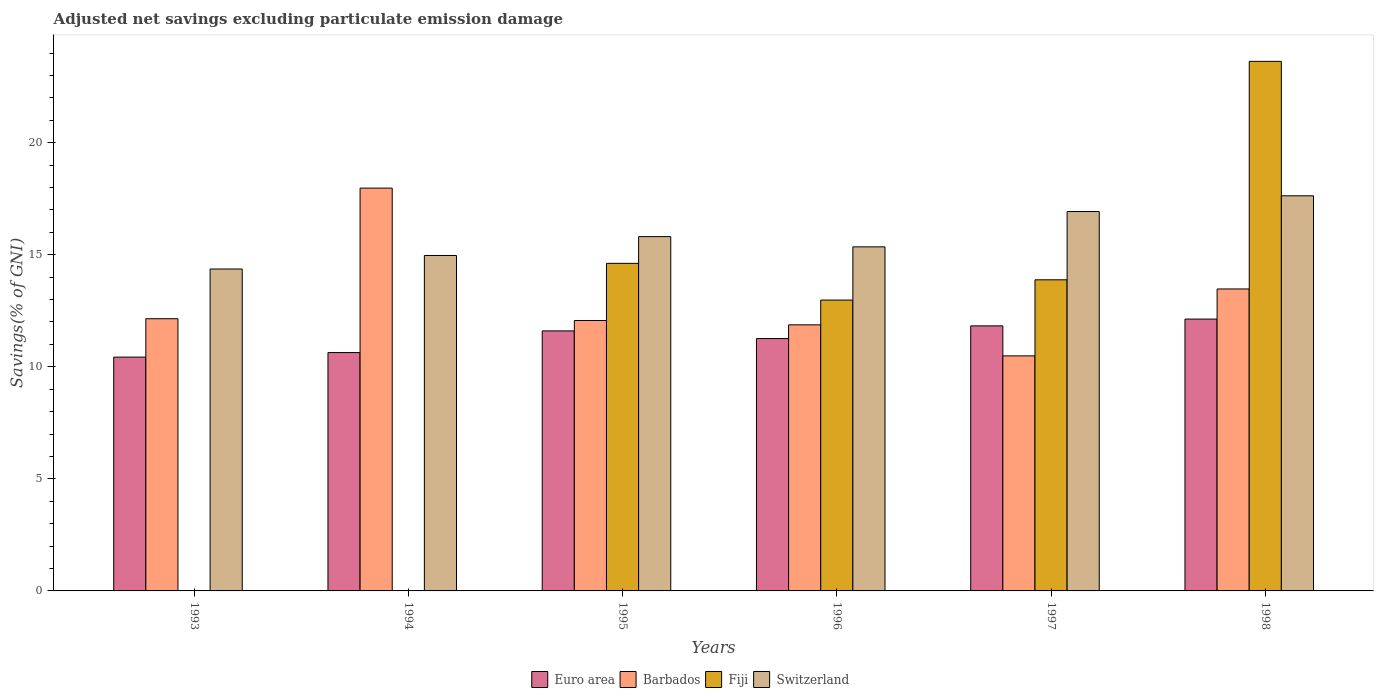How many different coloured bars are there?
Keep it short and to the point. 4. How many groups of bars are there?
Your answer should be very brief. 6. Are the number of bars per tick equal to the number of legend labels?
Your answer should be very brief. No. Are the number of bars on each tick of the X-axis equal?
Offer a very short reply. No. How many bars are there on the 4th tick from the left?
Offer a very short reply. 4. How many bars are there on the 6th tick from the right?
Ensure brevity in your answer.  3. What is the adjusted net savings in Switzerland in 1993?
Offer a very short reply. 14.36. Across all years, what is the maximum adjusted net savings in Euro area?
Make the answer very short. 12.13. Across all years, what is the minimum adjusted net savings in Barbados?
Give a very brief answer. 10.49. In which year was the adjusted net savings in Fiji maximum?
Make the answer very short. 1998. What is the total adjusted net savings in Switzerland in the graph?
Offer a very short reply. 95.05. What is the difference between the adjusted net savings in Switzerland in 1993 and that in 1996?
Give a very brief answer. -0.99. What is the difference between the adjusted net savings in Euro area in 1998 and the adjusted net savings in Switzerland in 1995?
Offer a terse response. -3.68. What is the average adjusted net savings in Euro area per year?
Keep it short and to the point. 11.31. In the year 1993, what is the difference between the adjusted net savings in Barbados and adjusted net savings in Euro area?
Your answer should be compact. 1.71. In how many years, is the adjusted net savings in Switzerland greater than 17 %?
Make the answer very short. 1. What is the ratio of the adjusted net savings in Euro area in 1993 to that in 1996?
Your answer should be compact. 0.93. What is the difference between the highest and the second highest adjusted net savings in Euro area?
Keep it short and to the point. 0.3. What is the difference between the highest and the lowest adjusted net savings in Switzerland?
Your answer should be compact. 3.27. In how many years, is the adjusted net savings in Barbados greater than the average adjusted net savings in Barbados taken over all years?
Your answer should be very brief. 2. Is it the case that in every year, the sum of the adjusted net savings in Euro area and adjusted net savings in Barbados is greater than the adjusted net savings in Fiji?
Make the answer very short. Yes. How many years are there in the graph?
Your response must be concise. 6. Are the values on the major ticks of Y-axis written in scientific E-notation?
Give a very brief answer. No. Does the graph contain any zero values?
Provide a succinct answer. Yes. Where does the legend appear in the graph?
Make the answer very short. Bottom center. How are the legend labels stacked?
Your answer should be compact. Horizontal. What is the title of the graph?
Provide a short and direct response. Adjusted net savings excluding particulate emission damage. Does "Mauritania" appear as one of the legend labels in the graph?
Provide a short and direct response. No. What is the label or title of the X-axis?
Ensure brevity in your answer.  Years. What is the label or title of the Y-axis?
Ensure brevity in your answer.  Savings(% of GNI). What is the Savings(% of GNI) of Euro area in 1993?
Offer a very short reply. 10.43. What is the Savings(% of GNI) of Barbados in 1993?
Make the answer very short. 12.15. What is the Savings(% of GNI) of Switzerland in 1993?
Keep it short and to the point. 14.36. What is the Savings(% of GNI) in Euro area in 1994?
Provide a short and direct response. 10.64. What is the Savings(% of GNI) in Barbados in 1994?
Ensure brevity in your answer.  17.97. What is the Savings(% of GNI) in Fiji in 1994?
Offer a terse response. 0. What is the Savings(% of GNI) of Switzerland in 1994?
Provide a succinct answer. 14.97. What is the Savings(% of GNI) of Euro area in 1995?
Provide a short and direct response. 11.6. What is the Savings(% of GNI) of Barbados in 1995?
Make the answer very short. 12.07. What is the Savings(% of GNI) in Fiji in 1995?
Give a very brief answer. 14.62. What is the Savings(% of GNI) in Switzerland in 1995?
Your answer should be very brief. 15.81. What is the Savings(% of GNI) in Euro area in 1996?
Keep it short and to the point. 11.26. What is the Savings(% of GNI) in Barbados in 1996?
Your response must be concise. 11.87. What is the Savings(% of GNI) in Fiji in 1996?
Your answer should be very brief. 12.98. What is the Savings(% of GNI) of Switzerland in 1996?
Your answer should be very brief. 15.35. What is the Savings(% of GNI) in Euro area in 1997?
Ensure brevity in your answer.  11.83. What is the Savings(% of GNI) of Barbados in 1997?
Keep it short and to the point. 10.49. What is the Savings(% of GNI) of Fiji in 1997?
Ensure brevity in your answer.  13.88. What is the Savings(% of GNI) of Switzerland in 1997?
Your answer should be very brief. 16.93. What is the Savings(% of GNI) of Euro area in 1998?
Your response must be concise. 12.13. What is the Savings(% of GNI) of Barbados in 1998?
Make the answer very short. 13.47. What is the Savings(% of GNI) of Fiji in 1998?
Provide a short and direct response. 23.63. What is the Savings(% of GNI) in Switzerland in 1998?
Provide a short and direct response. 17.63. Across all years, what is the maximum Savings(% of GNI) of Euro area?
Your response must be concise. 12.13. Across all years, what is the maximum Savings(% of GNI) in Barbados?
Make the answer very short. 17.97. Across all years, what is the maximum Savings(% of GNI) in Fiji?
Provide a succinct answer. 23.63. Across all years, what is the maximum Savings(% of GNI) of Switzerland?
Offer a terse response. 17.63. Across all years, what is the minimum Savings(% of GNI) of Euro area?
Your answer should be very brief. 10.43. Across all years, what is the minimum Savings(% of GNI) in Barbados?
Ensure brevity in your answer.  10.49. Across all years, what is the minimum Savings(% of GNI) in Fiji?
Ensure brevity in your answer.  0. Across all years, what is the minimum Savings(% of GNI) in Switzerland?
Keep it short and to the point. 14.36. What is the total Savings(% of GNI) of Euro area in the graph?
Ensure brevity in your answer.  67.89. What is the total Savings(% of GNI) of Barbados in the graph?
Make the answer very short. 78.02. What is the total Savings(% of GNI) of Fiji in the graph?
Your answer should be very brief. 65.1. What is the total Savings(% of GNI) in Switzerland in the graph?
Your answer should be compact. 95.05. What is the difference between the Savings(% of GNI) in Euro area in 1993 and that in 1994?
Your answer should be compact. -0.2. What is the difference between the Savings(% of GNI) of Barbados in 1993 and that in 1994?
Your answer should be very brief. -5.83. What is the difference between the Savings(% of GNI) of Switzerland in 1993 and that in 1994?
Make the answer very short. -0.6. What is the difference between the Savings(% of GNI) of Euro area in 1993 and that in 1995?
Offer a terse response. -1.17. What is the difference between the Savings(% of GNI) in Barbados in 1993 and that in 1995?
Ensure brevity in your answer.  0.08. What is the difference between the Savings(% of GNI) of Switzerland in 1993 and that in 1995?
Make the answer very short. -1.45. What is the difference between the Savings(% of GNI) in Euro area in 1993 and that in 1996?
Provide a succinct answer. -0.83. What is the difference between the Savings(% of GNI) of Barbados in 1993 and that in 1996?
Offer a very short reply. 0.27. What is the difference between the Savings(% of GNI) of Switzerland in 1993 and that in 1996?
Provide a succinct answer. -0.99. What is the difference between the Savings(% of GNI) in Euro area in 1993 and that in 1997?
Your response must be concise. -1.39. What is the difference between the Savings(% of GNI) of Barbados in 1993 and that in 1997?
Ensure brevity in your answer.  1.66. What is the difference between the Savings(% of GNI) in Switzerland in 1993 and that in 1997?
Your answer should be compact. -2.56. What is the difference between the Savings(% of GNI) in Euro area in 1993 and that in 1998?
Provide a short and direct response. -1.7. What is the difference between the Savings(% of GNI) of Barbados in 1993 and that in 1998?
Provide a succinct answer. -1.33. What is the difference between the Savings(% of GNI) in Switzerland in 1993 and that in 1998?
Your answer should be very brief. -3.27. What is the difference between the Savings(% of GNI) in Euro area in 1994 and that in 1995?
Provide a short and direct response. -0.97. What is the difference between the Savings(% of GNI) in Barbados in 1994 and that in 1995?
Provide a short and direct response. 5.91. What is the difference between the Savings(% of GNI) in Switzerland in 1994 and that in 1995?
Your response must be concise. -0.84. What is the difference between the Savings(% of GNI) in Euro area in 1994 and that in 1996?
Offer a very short reply. -0.62. What is the difference between the Savings(% of GNI) of Barbados in 1994 and that in 1996?
Provide a succinct answer. 6.1. What is the difference between the Savings(% of GNI) of Switzerland in 1994 and that in 1996?
Give a very brief answer. -0.39. What is the difference between the Savings(% of GNI) of Euro area in 1994 and that in 1997?
Your answer should be very brief. -1.19. What is the difference between the Savings(% of GNI) of Barbados in 1994 and that in 1997?
Provide a succinct answer. 7.49. What is the difference between the Savings(% of GNI) of Switzerland in 1994 and that in 1997?
Offer a very short reply. -1.96. What is the difference between the Savings(% of GNI) in Euro area in 1994 and that in 1998?
Ensure brevity in your answer.  -1.49. What is the difference between the Savings(% of GNI) in Barbados in 1994 and that in 1998?
Make the answer very short. 4.5. What is the difference between the Savings(% of GNI) in Switzerland in 1994 and that in 1998?
Your answer should be compact. -2.66. What is the difference between the Savings(% of GNI) in Euro area in 1995 and that in 1996?
Make the answer very short. 0.34. What is the difference between the Savings(% of GNI) in Barbados in 1995 and that in 1996?
Offer a terse response. 0.19. What is the difference between the Savings(% of GNI) of Fiji in 1995 and that in 1996?
Keep it short and to the point. 1.64. What is the difference between the Savings(% of GNI) of Switzerland in 1995 and that in 1996?
Provide a short and direct response. 0.46. What is the difference between the Savings(% of GNI) of Euro area in 1995 and that in 1997?
Offer a terse response. -0.22. What is the difference between the Savings(% of GNI) in Barbados in 1995 and that in 1997?
Provide a succinct answer. 1.58. What is the difference between the Savings(% of GNI) of Fiji in 1995 and that in 1997?
Your answer should be compact. 0.73. What is the difference between the Savings(% of GNI) in Switzerland in 1995 and that in 1997?
Provide a succinct answer. -1.12. What is the difference between the Savings(% of GNI) in Euro area in 1995 and that in 1998?
Give a very brief answer. -0.53. What is the difference between the Savings(% of GNI) of Barbados in 1995 and that in 1998?
Offer a very short reply. -1.41. What is the difference between the Savings(% of GNI) in Fiji in 1995 and that in 1998?
Offer a terse response. -9.01. What is the difference between the Savings(% of GNI) of Switzerland in 1995 and that in 1998?
Ensure brevity in your answer.  -1.82. What is the difference between the Savings(% of GNI) of Euro area in 1996 and that in 1997?
Keep it short and to the point. -0.57. What is the difference between the Savings(% of GNI) of Barbados in 1996 and that in 1997?
Ensure brevity in your answer.  1.39. What is the difference between the Savings(% of GNI) of Fiji in 1996 and that in 1997?
Your response must be concise. -0.9. What is the difference between the Savings(% of GNI) in Switzerland in 1996 and that in 1997?
Provide a short and direct response. -1.58. What is the difference between the Savings(% of GNI) of Euro area in 1996 and that in 1998?
Give a very brief answer. -0.87. What is the difference between the Savings(% of GNI) of Barbados in 1996 and that in 1998?
Offer a very short reply. -1.6. What is the difference between the Savings(% of GNI) of Fiji in 1996 and that in 1998?
Provide a succinct answer. -10.65. What is the difference between the Savings(% of GNI) of Switzerland in 1996 and that in 1998?
Offer a terse response. -2.28. What is the difference between the Savings(% of GNI) of Euro area in 1997 and that in 1998?
Your response must be concise. -0.3. What is the difference between the Savings(% of GNI) in Barbados in 1997 and that in 1998?
Provide a short and direct response. -2.99. What is the difference between the Savings(% of GNI) of Fiji in 1997 and that in 1998?
Provide a succinct answer. -9.75. What is the difference between the Savings(% of GNI) of Switzerland in 1997 and that in 1998?
Offer a very short reply. -0.7. What is the difference between the Savings(% of GNI) of Euro area in 1993 and the Savings(% of GNI) of Barbados in 1994?
Provide a succinct answer. -7.54. What is the difference between the Savings(% of GNI) of Euro area in 1993 and the Savings(% of GNI) of Switzerland in 1994?
Provide a succinct answer. -4.53. What is the difference between the Savings(% of GNI) of Barbados in 1993 and the Savings(% of GNI) of Switzerland in 1994?
Ensure brevity in your answer.  -2.82. What is the difference between the Savings(% of GNI) of Euro area in 1993 and the Savings(% of GNI) of Barbados in 1995?
Offer a very short reply. -1.63. What is the difference between the Savings(% of GNI) of Euro area in 1993 and the Savings(% of GNI) of Fiji in 1995?
Your answer should be compact. -4.18. What is the difference between the Savings(% of GNI) in Euro area in 1993 and the Savings(% of GNI) in Switzerland in 1995?
Make the answer very short. -5.38. What is the difference between the Savings(% of GNI) of Barbados in 1993 and the Savings(% of GNI) of Fiji in 1995?
Offer a very short reply. -2.47. What is the difference between the Savings(% of GNI) in Barbados in 1993 and the Savings(% of GNI) in Switzerland in 1995?
Keep it short and to the point. -3.66. What is the difference between the Savings(% of GNI) of Euro area in 1993 and the Savings(% of GNI) of Barbados in 1996?
Make the answer very short. -1.44. What is the difference between the Savings(% of GNI) of Euro area in 1993 and the Savings(% of GNI) of Fiji in 1996?
Provide a succinct answer. -2.55. What is the difference between the Savings(% of GNI) of Euro area in 1993 and the Savings(% of GNI) of Switzerland in 1996?
Your answer should be compact. -4.92. What is the difference between the Savings(% of GNI) in Barbados in 1993 and the Savings(% of GNI) in Fiji in 1996?
Make the answer very short. -0.83. What is the difference between the Savings(% of GNI) of Barbados in 1993 and the Savings(% of GNI) of Switzerland in 1996?
Provide a succinct answer. -3.21. What is the difference between the Savings(% of GNI) of Euro area in 1993 and the Savings(% of GNI) of Barbados in 1997?
Keep it short and to the point. -0.06. What is the difference between the Savings(% of GNI) of Euro area in 1993 and the Savings(% of GNI) of Fiji in 1997?
Offer a terse response. -3.45. What is the difference between the Savings(% of GNI) of Euro area in 1993 and the Savings(% of GNI) of Switzerland in 1997?
Make the answer very short. -6.5. What is the difference between the Savings(% of GNI) of Barbados in 1993 and the Savings(% of GNI) of Fiji in 1997?
Offer a very short reply. -1.74. What is the difference between the Savings(% of GNI) in Barbados in 1993 and the Savings(% of GNI) in Switzerland in 1997?
Provide a short and direct response. -4.78. What is the difference between the Savings(% of GNI) of Euro area in 1993 and the Savings(% of GNI) of Barbados in 1998?
Your answer should be very brief. -3.04. What is the difference between the Savings(% of GNI) in Euro area in 1993 and the Savings(% of GNI) in Fiji in 1998?
Keep it short and to the point. -13.2. What is the difference between the Savings(% of GNI) of Euro area in 1993 and the Savings(% of GNI) of Switzerland in 1998?
Your answer should be very brief. -7.2. What is the difference between the Savings(% of GNI) of Barbados in 1993 and the Savings(% of GNI) of Fiji in 1998?
Ensure brevity in your answer.  -11.48. What is the difference between the Savings(% of GNI) in Barbados in 1993 and the Savings(% of GNI) in Switzerland in 1998?
Ensure brevity in your answer.  -5.48. What is the difference between the Savings(% of GNI) of Euro area in 1994 and the Savings(% of GNI) of Barbados in 1995?
Keep it short and to the point. -1.43. What is the difference between the Savings(% of GNI) of Euro area in 1994 and the Savings(% of GNI) of Fiji in 1995?
Your response must be concise. -3.98. What is the difference between the Savings(% of GNI) of Euro area in 1994 and the Savings(% of GNI) of Switzerland in 1995?
Provide a short and direct response. -5.17. What is the difference between the Savings(% of GNI) in Barbados in 1994 and the Savings(% of GNI) in Fiji in 1995?
Your answer should be very brief. 3.36. What is the difference between the Savings(% of GNI) in Barbados in 1994 and the Savings(% of GNI) in Switzerland in 1995?
Your answer should be compact. 2.16. What is the difference between the Savings(% of GNI) in Euro area in 1994 and the Savings(% of GNI) in Barbados in 1996?
Offer a terse response. -1.24. What is the difference between the Savings(% of GNI) in Euro area in 1994 and the Savings(% of GNI) in Fiji in 1996?
Offer a terse response. -2.34. What is the difference between the Savings(% of GNI) in Euro area in 1994 and the Savings(% of GNI) in Switzerland in 1996?
Your answer should be very brief. -4.72. What is the difference between the Savings(% of GNI) of Barbados in 1994 and the Savings(% of GNI) of Fiji in 1996?
Ensure brevity in your answer.  5. What is the difference between the Savings(% of GNI) in Barbados in 1994 and the Savings(% of GNI) in Switzerland in 1996?
Your answer should be compact. 2.62. What is the difference between the Savings(% of GNI) of Euro area in 1994 and the Savings(% of GNI) of Barbados in 1997?
Provide a short and direct response. 0.15. What is the difference between the Savings(% of GNI) of Euro area in 1994 and the Savings(% of GNI) of Fiji in 1997?
Provide a short and direct response. -3.25. What is the difference between the Savings(% of GNI) of Euro area in 1994 and the Savings(% of GNI) of Switzerland in 1997?
Your response must be concise. -6.29. What is the difference between the Savings(% of GNI) in Barbados in 1994 and the Savings(% of GNI) in Fiji in 1997?
Your answer should be compact. 4.09. What is the difference between the Savings(% of GNI) in Barbados in 1994 and the Savings(% of GNI) in Switzerland in 1997?
Give a very brief answer. 1.05. What is the difference between the Savings(% of GNI) in Euro area in 1994 and the Savings(% of GNI) in Barbados in 1998?
Offer a terse response. -2.84. What is the difference between the Savings(% of GNI) of Euro area in 1994 and the Savings(% of GNI) of Fiji in 1998?
Provide a short and direct response. -12.99. What is the difference between the Savings(% of GNI) in Euro area in 1994 and the Savings(% of GNI) in Switzerland in 1998?
Offer a terse response. -6.99. What is the difference between the Savings(% of GNI) of Barbados in 1994 and the Savings(% of GNI) of Fiji in 1998?
Your response must be concise. -5.66. What is the difference between the Savings(% of GNI) of Barbados in 1994 and the Savings(% of GNI) of Switzerland in 1998?
Your answer should be very brief. 0.34. What is the difference between the Savings(% of GNI) of Euro area in 1995 and the Savings(% of GNI) of Barbados in 1996?
Offer a terse response. -0.27. What is the difference between the Savings(% of GNI) of Euro area in 1995 and the Savings(% of GNI) of Fiji in 1996?
Your answer should be very brief. -1.37. What is the difference between the Savings(% of GNI) of Euro area in 1995 and the Savings(% of GNI) of Switzerland in 1996?
Provide a short and direct response. -3.75. What is the difference between the Savings(% of GNI) in Barbados in 1995 and the Savings(% of GNI) in Fiji in 1996?
Provide a succinct answer. -0.91. What is the difference between the Savings(% of GNI) of Barbados in 1995 and the Savings(% of GNI) of Switzerland in 1996?
Provide a succinct answer. -3.29. What is the difference between the Savings(% of GNI) of Fiji in 1995 and the Savings(% of GNI) of Switzerland in 1996?
Offer a terse response. -0.74. What is the difference between the Savings(% of GNI) in Euro area in 1995 and the Savings(% of GNI) in Barbados in 1997?
Give a very brief answer. 1.12. What is the difference between the Savings(% of GNI) of Euro area in 1995 and the Savings(% of GNI) of Fiji in 1997?
Your answer should be compact. -2.28. What is the difference between the Savings(% of GNI) in Euro area in 1995 and the Savings(% of GNI) in Switzerland in 1997?
Provide a succinct answer. -5.33. What is the difference between the Savings(% of GNI) of Barbados in 1995 and the Savings(% of GNI) of Fiji in 1997?
Make the answer very short. -1.82. What is the difference between the Savings(% of GNI) in Barbados in 1995 and the Savings(% of GNI) in Switzerland in 1997?
Your answer should be very brief. -4.86. What is the difference between the Savings(% of GNI) of Fiji in 1995 and the Savings(% of GNI) of Switzerland in 1997?
Make the answer very short. -2.31. What is the difference between the Savings(% of GNI) of Euro area in 1995 and the Savings(% of GNI) of Barbados in 1998?
Offer a very short reply. -1.87. What is the difference between the Savings(% of GNI) of Euro area in 1995 and the Savings(% of GNI) of Fiji in 1998?
Provide a short and direct response. -12.03. What is the difference between the Savings(% of GNI) of Euro area in 1995 and the Savings(% of GNI) of Switzerland in 1998?
Ensure brevity in your answer.  -6.03. What is the difference between the Savings(% of GNI) in Barbados in 1995 and the Savings(% of GNI) in Fiji in 1998?
Make the answer very short. -11.56. What is the difference between the Savings(% of GNI) in Barbados in 1995 and the Savings(% of GNI) in Switzerland in 1998?
Your answer should be compact. -5.56. What is the difference between the Savings(% of GNI) of Fiji in 1995 and the Savings(% of GNI) of Switzerland in 1998?
Your response must be concise. -3.01. What is the difference between the Savings(% of GNI) of Euro area in 1996 and the Savings(% of GNI) of Barbados in 1997?
Give a very brief answer. 0.77. What is the difference between the Savings(% of GNI) in Euro area in 1996 and the Savings(% of GNI) in Fiji in 1997?
Ensure brevity in your answer.  -2.62. What is the difference between the Savings(% of GNI) of Euro area in 1996 and the Savings(% of GNI) of Switzerland in 1997?
Give a very brief answer. -5.67. What is the difference between the Savings(% of GNI) in Barbados in 1996 and the Savings(% of GNI) in Fiji in 1997?
Give a very brief answer. -2.01. What is the difference between the Savings(% of GNI) of Barbados in 1996 and the Savings(% of GNI) of Switzerland in 1997?
Your answer should be very brief. -5.06. What is the difference between the Savings(% of GNI) of Fiji in 1996 and the Savings(% of GNI) of Switzerland in 1997?
Your answer should be compact. -3.95. What is the difference between the Savings(% of GNI) in Euro area in 1996 and the Savings(% of GNI) in Barbados in 1998?
Your answer should be compact. -2.21. What is the difference between the Savings(% of GNI) in Euro area in 1996 and the Savings(% of GNI) in Fiji in 1998?
Your answer should be very brief. -12.37. What is the difference between the Savings(% of GNI) of Euro area in 1996 and the Savings(% of GNI) of Switzerland in 1998?
Make the answer very short. -6.37. What is the difference between the Savings(% of GNI) of Barbados in 1996 and the Savings(% of GNI) of Fiji in 1998?
Your answer should be compact. -11.76. What is the difference between the Savings(% of GNI) of Barbados in 1996 and the Savings(% of GNI) of Switzerland in 1998?
Ensure brevity in your answer.  -5.76. What is the difference between the Savings(% of GNI) of Fiji in 1996 and the Savings(% of GNI) of Switzerland in 1998?
Your response must be concise. -4.65. What is the difference between the Savings(% of GNI) of Euro area in 1997 and the Savings(% of GNI) of Barbados in 1998?
Provide a short and direct response. -1.65. What is the difference between the Savings(% of GNI) of Euro area in 1997 and the Savings(% of GNI) of Fiji in 1998?
Ensure brevity in your answer.  -11.8. What is the difference between the Savings(% of GNI) of Euro area in 1997 and the Savings(% of GNI) of Switzerland in 1998?
Ensure brevity in your answer.  -5.8. What is the difference between the Savings(% of GNI) in Barbados in 1997 and the Savings(% of GNI) in Fiji in 1998?
Offer a terse response. -13.14. What is the difference between the Savings(% of GNI) in Barbados in 1997 and the Savings(% of GNI) in Switzerland in 1998?
Your answer should be compact. -7.14. What is the difference between the Savings(% of GNI) of Fiji in 1997 and the Savings(% of GNI) of Switzerland in 1998?
Your response must be concise. -3.75. What is the average Savings(% of GNI) in Euro area per year?
Make the answer very short. 11.31. What is the average Savings(% of GNI) in Barbados per year?
Give a very brief answer. 13. What is the average Savings(% of GNI) of Fiji per year?
Your answer should be compact. 10.85. What is the average Savings(% of GNI) in Switzerland per year?
Your answer should be compact. 15.84. In the year 1993, what is the difference between the Savings(% of GNI) of Euro area and Savings(% of GNI) of Barbados?
Make the answer very short. -1.71. In the year 1993, what is the difference between the Savings(% of GNI) of Euro area and Savings(% of GNI) of Switzerland?
Provide a short and direct response. -3.93. In the year 1993, what is the difference between the Savings(% of GNI) of Barbados and Savings(% of GNI) of Switzerland?
Provide a short and direct response. -2.22. In the year 1994, what is the difference between the Savings(% of GNI) in Euro area and Savings(% of GNI) in Barbados?
Make the answer very short. -7.34. In the year 1994, what is the difference between the Savings(% of GNI) in Euro area and Savings(% of GNI) in Switzerland?
Give a very brief answer. -4.33. In the year 1994, what is the difference between the Savings(% of GNI) of Barbados and Savings(% of GNI) of Switzerland?
Ensure brevity in your answer.  3.01. In the year 1995, what is the difference between the Savings(% of GNI) of Euro area and Savings(% of GNI) of Barbados?
Give a very brief answer. -0.46. In the year 1995, what is the difference between the Savings(% of GNI) in Euro area and Savings(% of GNI) in Fiji?
Your answer should be compact. -3.01. In the year 1995, what is the difference between the Savings(% of GNI) in Euro area and Savings(% of GNI) in Switzerland?
Keep it short and to the point. -4.21. In the year 1995, what is the difference between the Savings(% of GNI) of Barbados and Savings(% of GNI) of Fiji?
Offer a terse response. -2.55. In the year 1995, what is the difference between the Savings(% of GNI) in Barbados and Savings(% of GNI) in Switzerland?
Your response must be concise. -3.74. In the year 1995, what is the difference between the Savings(% of GNI) in Fiji and Savings(% of GNI) in Switzerland?
Ensure brevity in your answer.  -1.19. In the year 1996, what is the difference between the Savings(% of GNI) of Euro area and Savings(% of GNI) of Barbados?
Your answer should be compact. -0.61. In the year 1996, what is the difference between the Savings(% of GNI) in Euro area and Savings(% of GNI) in Fiji?
Make the answer very short. -1.72. In the year 1996, what is the difference between the Savings(% of GNI) of Euro area and Savings(% of GNI) of Switzerland?
Make the answer very short. -4.09. In the year 1996, what is the difference between the Savings(% of GNI) in Barbados and Savings(% of GNI) in Fiji?
Offer a very short reply. -1.1. In the year 1996, what is the difference between the Savings(% of GNI) in Barbados and Savings(% of GNI) in Switzerland?
Your answer should be very brief. -3.48. In the year 1996, what is the difference between the Savings(% of GNI) of Fiji and Savings(% of GNI) of Switzerland?
Provide a short and direct response. -2.38. In the year 1997, what is the difference between the Savings(% of GNI) of Euro area and Savings(% of GNI) of Barbados?
Your answer should be very brief. 1.34. In the year 1997, what is the difference between the Savings(% of GNI) of Euro area and Savings(% of GNI) of Fiji?
Keep it short and to the point. -2.06. In the year 1997, what is the difference between the Savings(% of GNI) of Euro area and Savings(% of GNI) of Switzerland?
Your answer should be very brief. -5.1. In the year 1997, what is the difference between the Savings(% of GNI) in Barbados and Savings(% of GNI) in Fiji?
Ensure brevity in your answer.  -3.39. In the year 1997, what is the difference between the Savings(% of GNI) in Barbados and Savings(% of GNI) in Switzerland?
Make the answer very short. -6.44. In the year 1997, what is the difference between the Savings(% of GNI) in Fiji and Savings(% of GNI) in Switzerland?
Your response must be concise. -3.05. In the year 1998, what is the difference between the Savings(% of GNI) in Euro area and Savings(% of GNI) in Barbados?
Provide a succinct answer. -1.34. In the year 1998, what is the difference between the Savings(% of GNI) of Euro area and Savings(% of GNI) of Fiji?
Keep it short and to the point. -11.5. In the year 1998, what is the difference between the Savings(% of GNI) in Euro area and Savings(% of GNI) in Switzerland?
Provide a short and direct response. -5.5. In the year 1998, what is the difference between the Savings(% of GNI) in Barbados and Savings(% of GNI) in Fiji?
Provide a short and direct response. -10.16. In the year 1998, what is the difference between the Savings(% of GNI) of Barbados and Savings(% of GNI) of Switzerland?
Provide a short and direct response. -4.16. In the year 1998, what is the difference between the Savings(% of GNI) of Fiji and Savings(% of GNI) of Switzerland?
Ensure brevity in your answer.  6. What is the ratio of the Savings(% of GNI) in Euro area in 1993 to that in 1994?
Your response must be concise. 0.98. What is the ratio of the Savings(% of GNI) of Barbados in 1993 to that in 1994?
Your answer should be compact. 0.68. What is the ratio of the Savings(% of GNI) of Switzerland in 1993 to that in 1994?
Give a very brief answer. 0.96. What is the ratio of the Savings(% of GNI) in Euro area in 1993 to that in 1995?
Your answer should be compact. 0.9. What is the ratio of the Savings(% of GNI) in Barbados in 1993 to that in 1995?
Your response must be concise. 1.01. What is the ratio of the Savings(% of GNI) of Switzerland in 1993 to that in 1995?
Your answer should be compact. 0.91. What is the ratio of the Savings(% of GNI) of Euro area in 1993 to that in 1996?
Give a very brief answer. 0.93. What is the ratio of the Savings(% of GNI) in Switzerland in 1993 to that in 1996?
Provide a succinct answer. 0.94. What is the ratio of the Savings(% of GNI) of Euro area in 1993 to that in 1997?
Offer a very short reply. 0.88. What is the ratio of the Savings(% of GNI) in Barbados in 1993 to that in 1997?
Your answer should be very brief. 1.16. What is the ratio of the Savings(% of GNI) of Switzerland in 1993 to that in 1997?
Offer a terse response. 0.85. What is the ratio of the Savings(% of GNI) of Euro area in 1993 to that in 1998?
Your answer should be very brief. 0.86. What is the ratio of the Savings(% of GNI) in Barbados in 1993 to that in 1998?
Give a very brief answer. 0.9. What is the ratio of the Savings(% of GNI) in Switzerland in 1993 to that in 1998?
Your answer should be compact. 0.81. What is the ratio of the Savings(% of GNI) of Euro area in 1994 to that in 1995?
Provide a short and direct response. 0.92. What is the ratio of the Savings(% of GNI) in Barbados in 1994 to that in 1995?
Your answer should be very brief. 1.49. What is the ratio of the Savings(% of GNI) of Switzerland in 1994 to that in 1995?
Keep it short and to the point. 0.95. What is the ratio of the Savings(% of GNI) of Euro area in 1994 to that in 1996?
Your response must be concise. 0.94. What is the ratio of the Savings(% of GNI) of Barbados in 1994 to that in 1996?
Your answer should be very brief. 1.51. What is the ratio of the Savings(% of GNI) in Switzerland in 1994 to that in 1996?
Offer a terse response. 0.97. What is the ratio of the Savings(% of GNI) of Euro area in 1994 to that in 1997?
Keep it short and to the point. 0.9. What is the ratio of the Savings(% of GNI) of Barbados in 1994 to that in 1997?
Provide a short and direct response. 1.71. What is the ratio of the Savings(% of GNI) in Switzerland in 1994 to that in 1997?
Your answer should be compact. 0.88. What is the ratio of the Savings(% of GNI) in Euro area in 1994 to that in 1998?
Provide a short and direct response. 0.88. What is the ratio of the Savings(% of GNI) in Barbados in 1994 to that in 1998?
Make the answer very short. 1.33. What is the ratio of the Savings(% of GNI) of Switzerland in 1994 to that in 1998?
Offer a terse response. 0.85. What is the ratio of the Savings(% of GNI) of Euro area in 1995 to that in 1996?
Your answer should be very brief. 1.03. What is the ratio of the Savings(% of GNI) in Barbados in 1995 to that in 1996?
Your answer should be compact. 1.02. What is the ratio of the Savings(% of GNI) of Fiji in 1995 to that in 1996?
Make the answer very short. 1.13. What is the ratio of the Savings(% of GNI) of Switzerland in 1995 to that in 1996?
Your response must be concise. 1.03. What is the ratio of the Savings(% of GNI) of Barbados in 1995 to that in 1997?
Provide a short and direct response. 1.15. What is the ratio of the Savings(% of GNI) in Fiji in 1995 to that in 1997?
Your response must be concise. 1.05. What is the ratio of the Savings(% of GNI) of Switzerland in 1995 to that in 1997?
Provide a succinct answer. 0.93. What is the ratio of the Savings(% of GNI) in Euro area in 1995 to that in 1998?
Your response must be concise. 0.96. What is the ratio of the Savings(% of GNI) in Barbados in 1995 to that in 1998?
Your answer should be very brief. 0.9. What is the ratio of the Savings(% of GNI) in Fiji in 1995 to that in 1998?
Offer a terse response. 0.62. What is the ratio of the Savings(% of GNI) in Switzerland in 1995 to that in 1998?
Give a very brief answer. 0.9. What is the ratio of the Savings(% of GNI) in Euro area in 1996 to that in 1997?
Offer a terse response. 0.95. What is the ratio of the Savings(% of GNI) in Barbados in 1996 to that in 1997?
Provide a short and direct response. 1.13. What is the ratio of the Savings(% of GNI) of Fiji in 1996 to that in 1997?
Your response must be concise. 0.93. What is the ratio of the Savings(% of GNI) in Switzerland in 1996 to that in 1997?
Provide a short and direct response. 0.91. What is the ratio of the Savings(% of GNI) of Euro area in 1996 to that in 1998?
Your answer should be very brief. 0.93. What is the ratio of the Savings(% of GNI) of Barbados in 1996 to that in 1998?
Your response must be concise. 0.88. What is the ratio of the Savings(% of GNI) of Fiji in 1996 to that in 1998?
Keep it short and to the point. 0.55. What is the ratio of the Savings(% of GNI) of Switzerland in 1996 to that in 1998?
Provide a succinct answer. 0.87. What is the ratio of the Savings(% of GNI) of Barbados in 1997 to that in 1998?
Ensure brevity in your answer.  0.78. What is the ratio of the Savings(% of GNI) of Fiji in 1997 to that in 1998?
Ensure brevity in your answer.  0.59. What is the ratio of the Savings(% of GNI) in Switzerland in 1997 to that in 1998?
Your response must be concise. 0.96. What is the difference between the highest and the second highest Savings(% of GNI) of Euro area?
Offer a very short reply. 0.3. What is the difference between the highest and the second highest Savings(% of GNI) in Barbados?
Offer a terse response. 4.5. What is the difference between the highest and the second highest Savings(% of GNI) in Fiji?
Keep it short and to the point. 9.01. What is the difference between the highest and the second highest Savings(% of GNI) in Switzerland?
Provide a short and direct response. 0.7. What is the difference between the highest and the lowest Savings(% of GNI) of Euro area?
Your response must be concise. 1.7. What is the difference between the highest and the lowest Savings(% of GNI) of Barbados?
Make the answer very short. 7.49. What is the difference between the highest and the lowest Savings(% of GNI) in Fiji?
Provide a short and direct response. 23.63. What is the difference between the highest and the lowest Savings(% of GNI) in Switzerland?
Offer a very short reply. 3.27. 